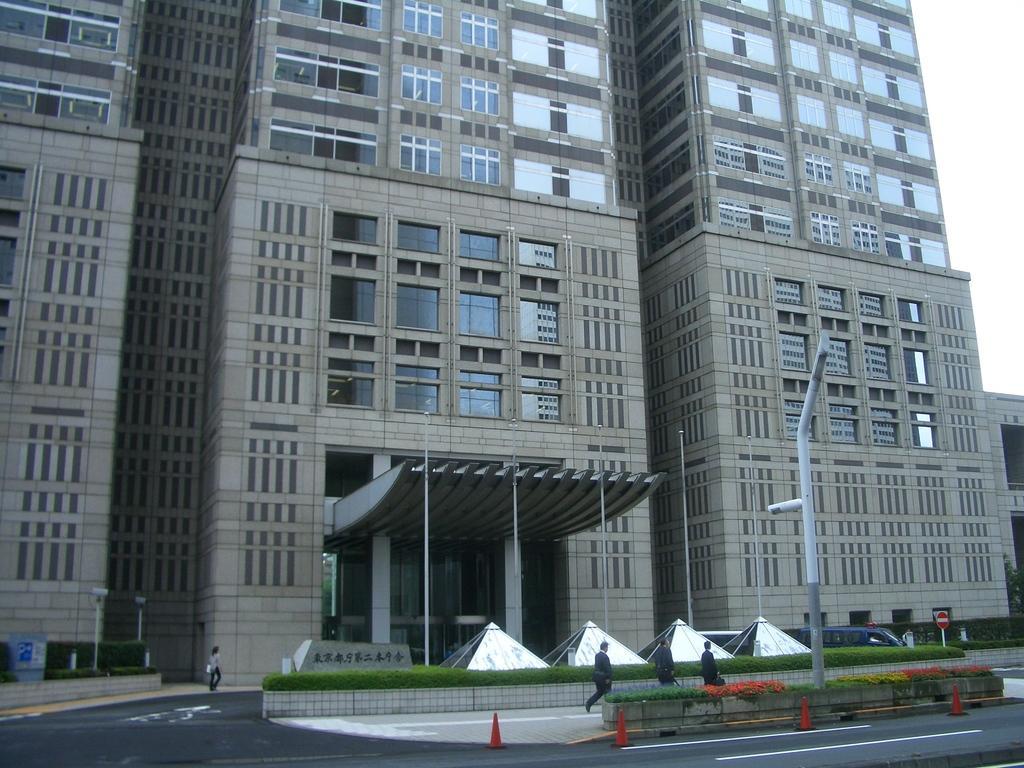How would you summarize this image in a sentence or two? In this picture we can see the buildings, windows, roof, door. At the bottom of the image we can see the road, divider cones, plants, flowers, sheds, vehicle, poles, board, bushes and some people are walking on the road. In the top right corner we can see the sky. 